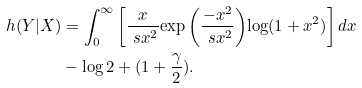<formula> <loc_0><loc_0><loc_500><loc_500>h ( Y | X ) & = { \int _ { 0 } ^ { \infty } \left [ { \frac { x } { \ s x ^ { 2 } } { \exp \left ( { \frac { - x ^ { 2 } } { \ s x ^ { 2 } } } \right ) } } { \log ( 1 + x ^ { 2 } ) } \right ] { d x } } \\ & - { \log { 2 } } + ( { 1 + \frac { \gamma } { 2 } } ) .</formula> 